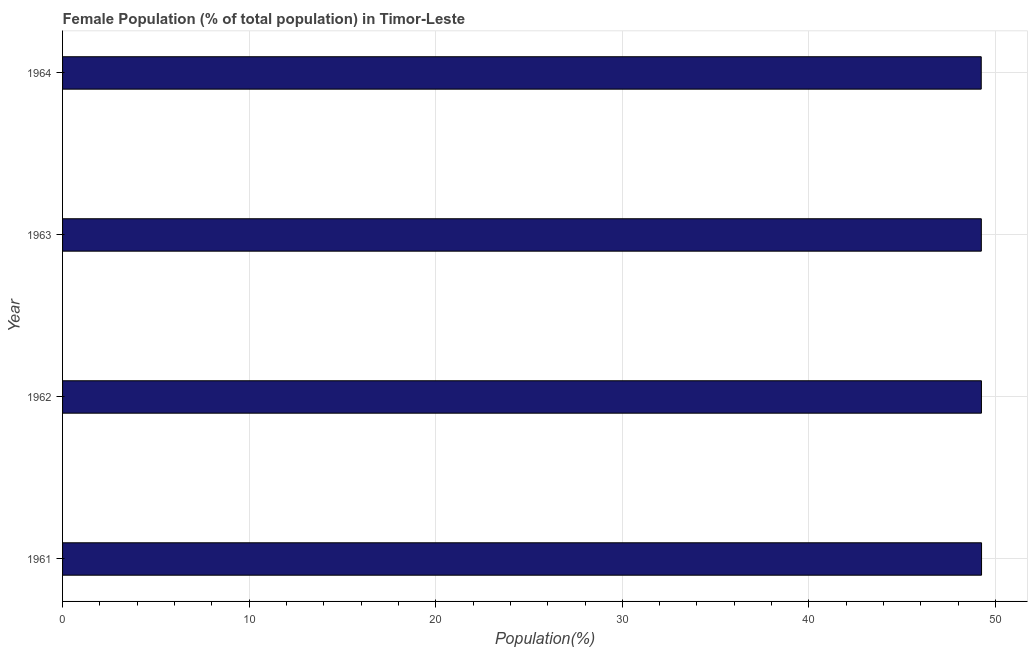What is the title of the graph?
Keep it short and to the point. Female Population (% of total population) in Timor-Leste. What is the label or title of the X-axis?
Make the answer very short. Population(%). What is the female population in 1964?
Your answer should be very brief. 49.23. Across all years, what is the maximum female population?
Make the answer very short. 49.25. Across all years, what is the minimum female population?
Offer a terse response. 49.23. In which year was the female population minimum?
Ensure brevity in your answer.  1964. What is the sum of the female population?
Provide a succinct answer. 196.97. What is the difference between the female population in 1962 and 1964?
Provide a succinct answer. 0.01. What is the average female population per year?
Provide a short and direct response. 49.24. What is the median female population?
Make the answer very short. 49.24. Is the female population in 1962 less than that in 1963?
Give a very brief answer. No. What is the difference between the highest and the second highest female population?
Give a very brief answer. 0.01. Is the sum of the female population in 1962 and 1964 greater than the maximum female population across all years?
Keep it short and to the point. Yes. What is the difference between the highest and the lowest female population?
Your answer should be very brief. 0.02. Are all the bars in the graph horizontal?
Offer a very short reply. Yes. How many years are there in the graph?
Give a very brief answer. 4. What is the difference between two consecutive major ticks on the X-axis?
Make the answer very short. 10. What is the Population(%) in 1961?
Make the answer very short. 49.25. What is the Population(%) of 1962?
Offer a very short reply. 49.25. What is the Population(%) of 1963?
Provide a succinct answer. 49.24. What is the Population(%) of 1964?
Your response must be concise. 49.23. What is the difference between the Population(%) in 1961 and 1962?
Ensure brevity in your answer.  0.01. What is the difference between the Population(%) in 1961 and 1963?
Your response must be concise. 0.01. What is the difference between the Population(%) in 1961 and 1964?
Provide a succinct answer. 0.02. What is the difference between the Population(%) in 1962 and 1963?
Your answer should be very brief. 0.01. What is the difference between the Population(%) in 1962 and 1964?
Offer a very short reply. 0.01. What is the difference between the Population(%) in 1963 and 1964?
Provide a short and direct response. 0.01. What is the ratio of the Population(%) in 1961 to that in 1962?
Give a very brief answer. 1. What is the ratio of the Population(%) in 1961 to that in 1964?
Your answer should be very brief. 1. What is the ratio of the Population(%) in 1962 to that in 1963?
Offer a very short reply. 1. What is the ratio of the Population(%) in 1962 to that in 1964?
Your answer should be very brief. 1. What is the ratio of the Population(%) in 1963 to that in 1964?
Provide a succinct answer. 1. 